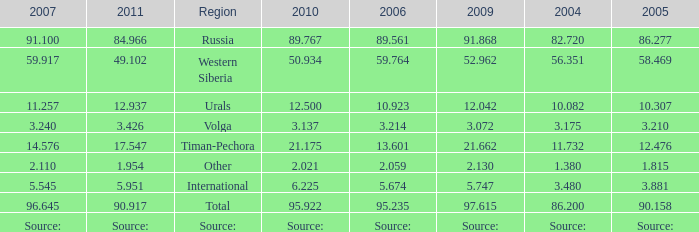What is the 2005 Lukoil oil prodroduction when in 2007 oil production 91.100 million tonnes? 86.277. 